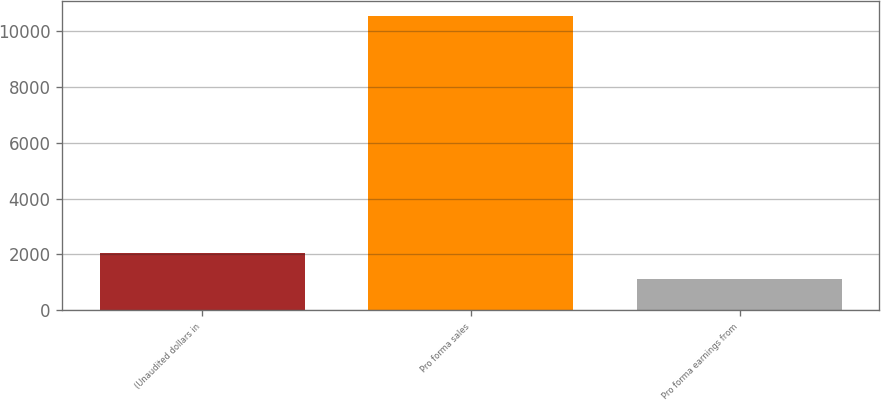Convert chart to OTSL. <chart><loc_0><loc_0><loc_500><loc_500><bar_chart><fcel>(Unaudited dollars in<fcel>Pro forma sales<fcel>Pro forma earnings from<nl><fcel>2045.9<fcel>10550<fcel>1101<nl></chart> 